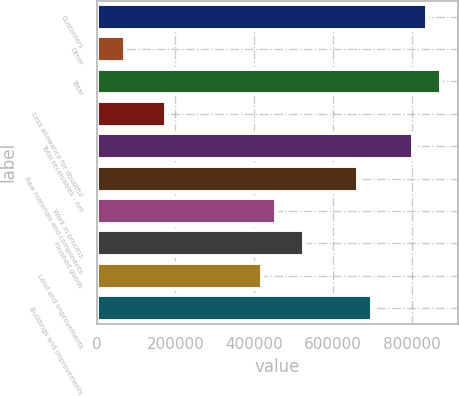Convert chart. <chart><loc_0><loc_0><loc_500><loc_500><bar_chart><fcel>Customers<fcel>Other<fcel>Total<fcel>Less allowance for doubtful<fcel>Total receivables - net<fcel>Raw materials and components<fcel>Work in process<fcel>Finished goods<fcel>Land and improvements<fcel>Buildings and improvements<nl><fcel>838841<fcel>72359.2<fcel>873682<fcel>176880<fcel>804001<fcel>664641<fcel>455600<fcel>525280<fcel>420760<fcel>699481<nl></chart> 